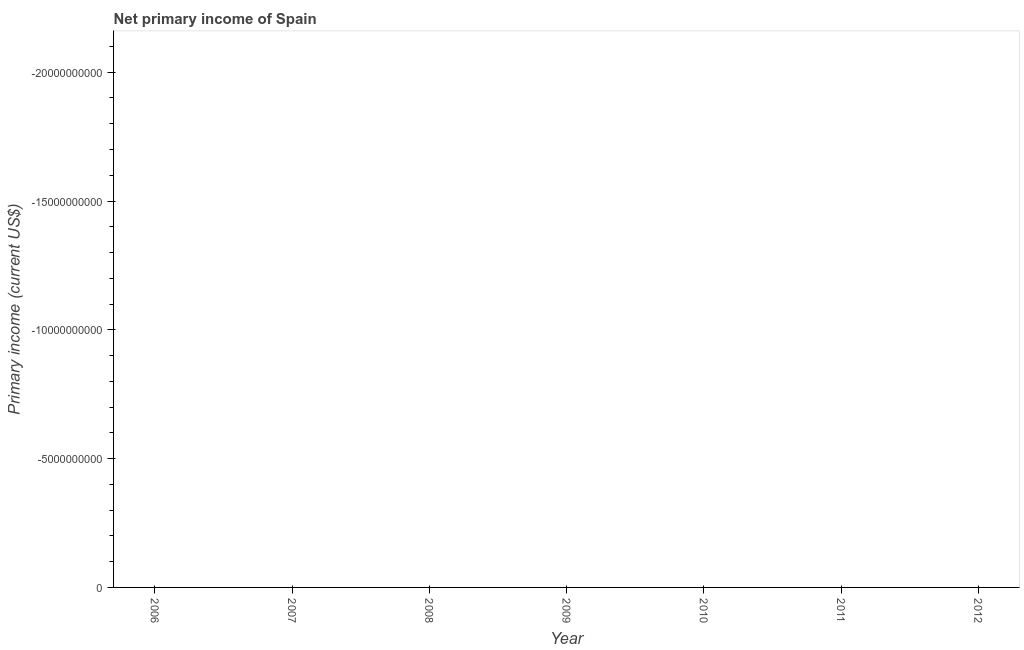What is the amount of primary income in 2007?
Keep it short and to the point. 0. What is the sum of the amount of primary income?
Give a very brief answer. 0. What is the average amount of primary income per year?
Your response must be concise. 0. In how many years, is the amount of primary income greater than -19000000000 US$?
Ensure brevity in your answer.  0. How many dotlines are there?
Offer a very short reply. 0. How many years are there in the graph?
Provide a short and direct response. 7. What is the difference between two consecutive major ticks on the Y-axis?
Your answer should be very brief. 5.00e+09. Are the values on the major ticks of Y-axis written in scientific E-notation?
Your response must be concise. No. Does the graph contain grids?
Ensure brevity in your answer.  No. What is the title of the graph?
Give a very brief answer. Net primary income of Spain. What is the label or title of the Y-axis?
Offer a very short reply. Primary income (current US$). What is the Primary income (current US$) in 2007?
Provide a short and direct response. 0. What is the Primary income (current US$) in 2009?
Your response must be concise. 0. What is the Primary income (current US$) in 2011?
Provide a short and direct response. 0. What is the Primary income (current US$) in 2012?
Provide a succinct answer. 0. 